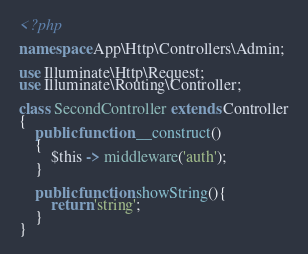Convert code to text. <code><loc_0><loc_0><loc_500><loc_500><_PHP_><?php

namespace App\Http\Controllers\Admin;

use Illuminate\Http\Request;
use Illuminate\Routing\Controller;

class SecondController extends Controller
{
    public function __construct()
    {
        $this -> middleware('auth');
    }

    public function showString(){
        return 'string';
    }
}
</code> 